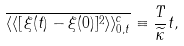<formula> <loc_0><loc_0><loc_500><loc_500>\overline { \langle \langle [ \xi ( t ) - \xi ( 0 ) ] ^ { 2 } \rangle \rangle ^ { c } _ { 0 , t } } \equiv \frac { T } { \widetilde { \kappa } } t ,</formula> 